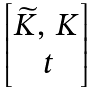Convert formula to latex. <formula><loc_0><loc_0><loc_500><loc_500>\begin{bmatrix} \widetilde { K } , \, K \\ \, t \end{bmatrix}</formula> 